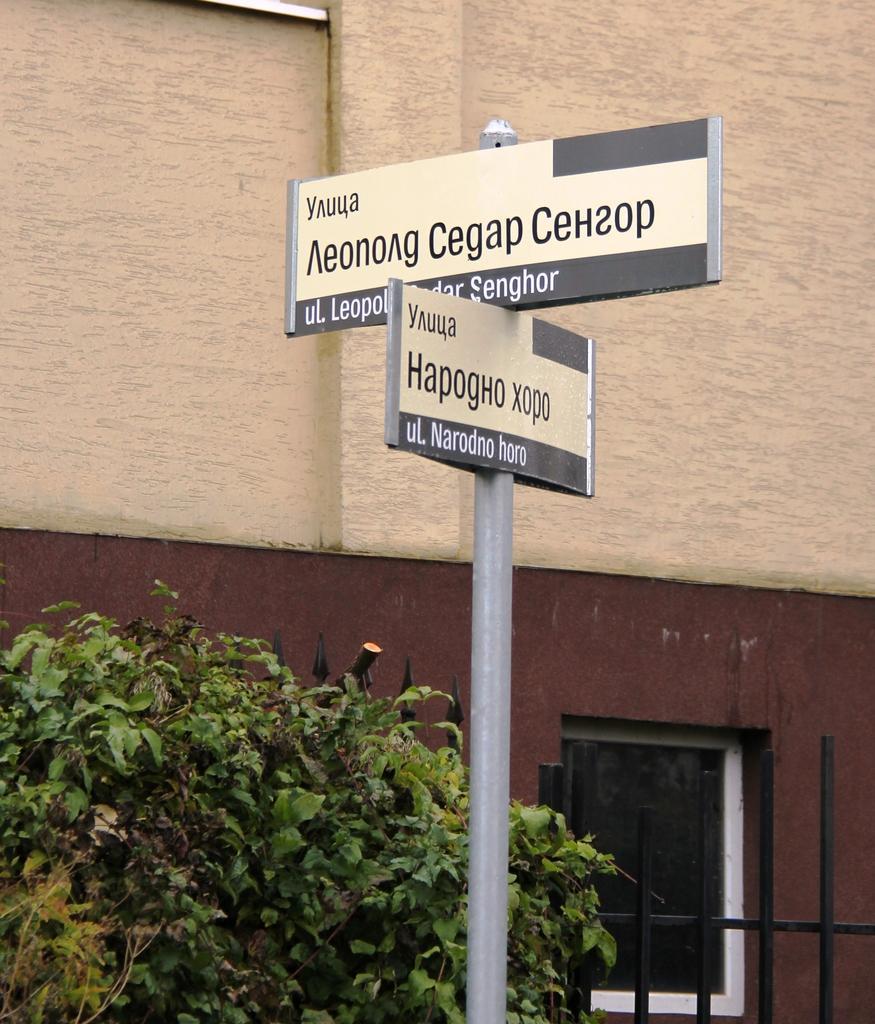In one or two sentences, can you explain what this image depicts? In the image there is a name board in the front with a plant beside it followed by a fence and building in the background. 